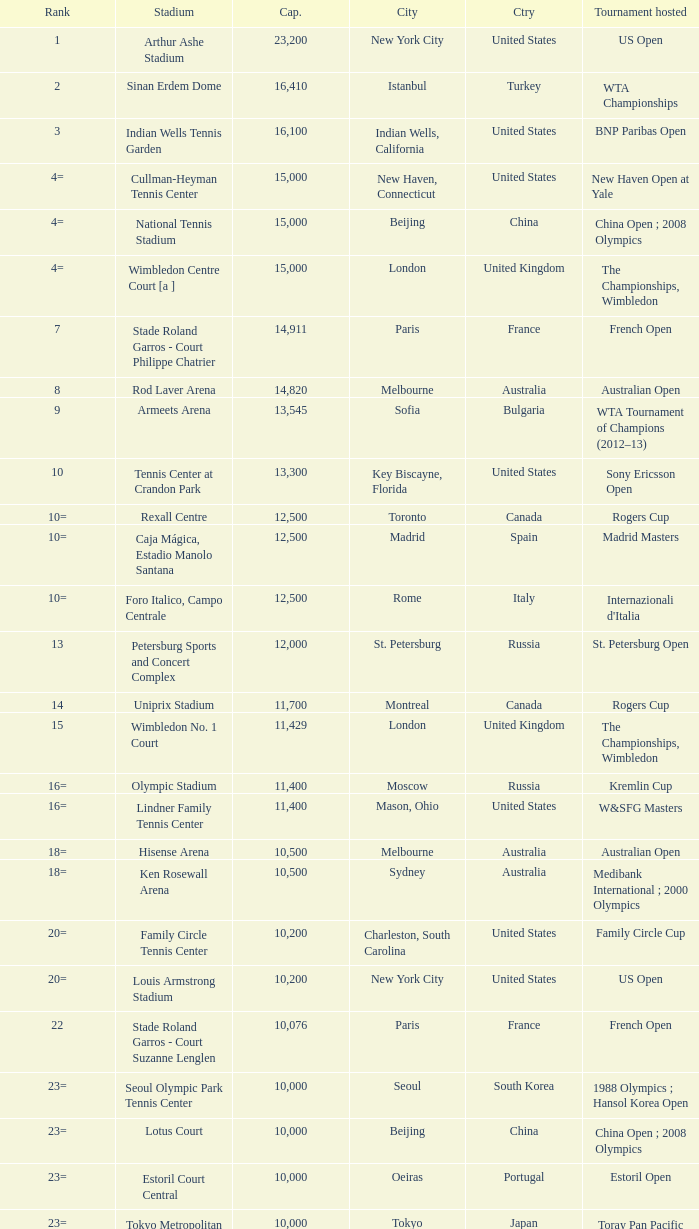What is the average capacity that has rod laver arena as the stadium? 14820.0. 